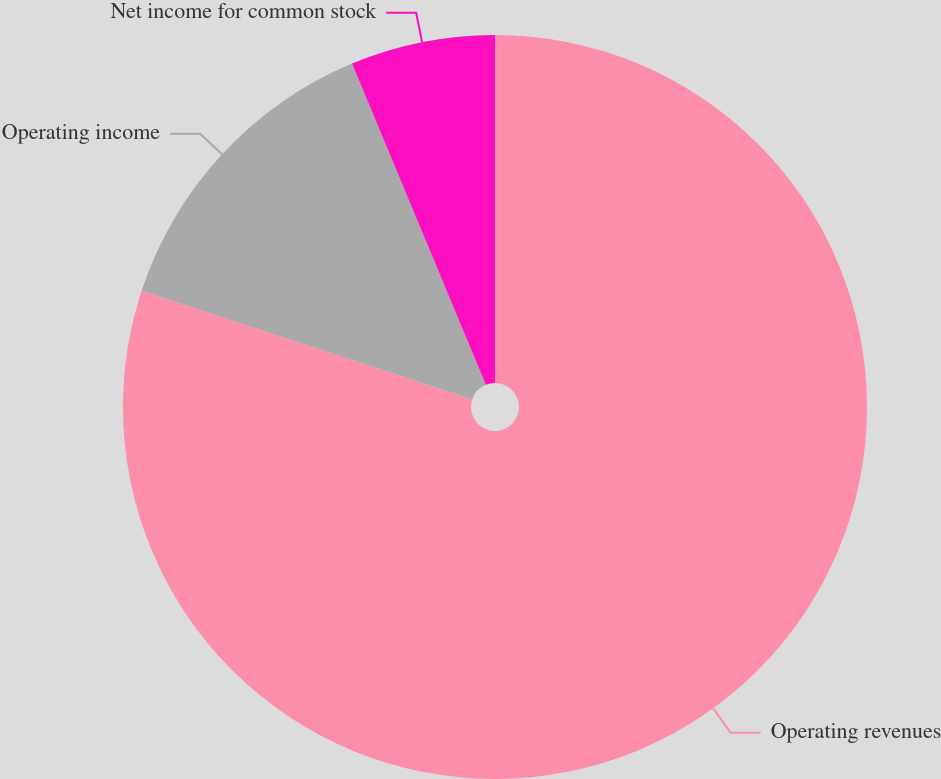Convert chart. <chart><loc_0><loc_0><loc_500><loc_500><pie_chart><fcel>Operating revenues<fcel>Operating income<fcel>Net income for common stock<nl><fcel>80.06%<fcel>13.66%<fcel>6.28%<nl></chart> 